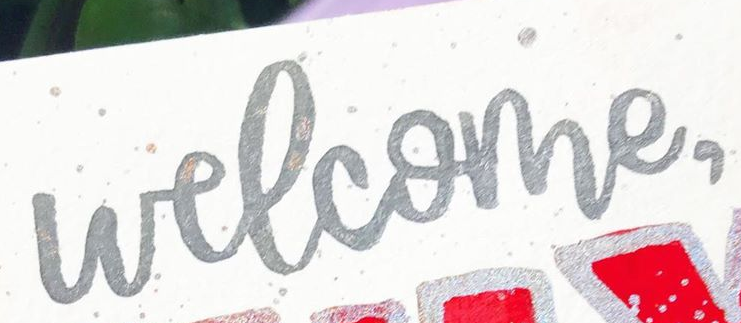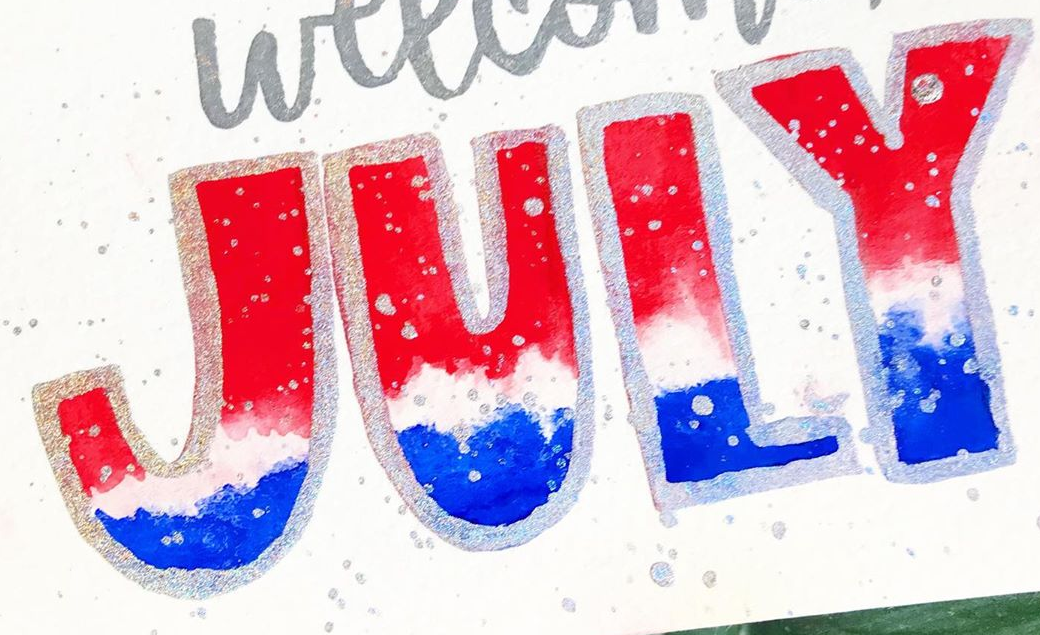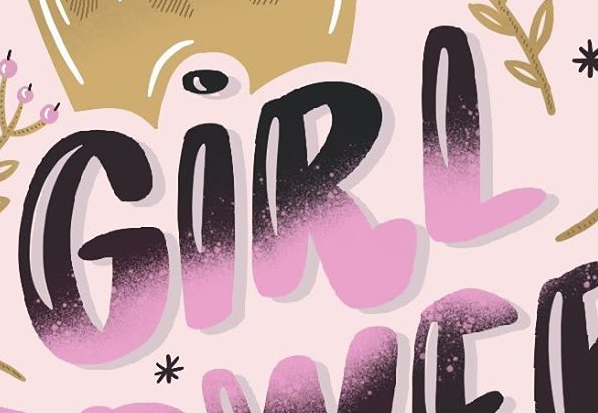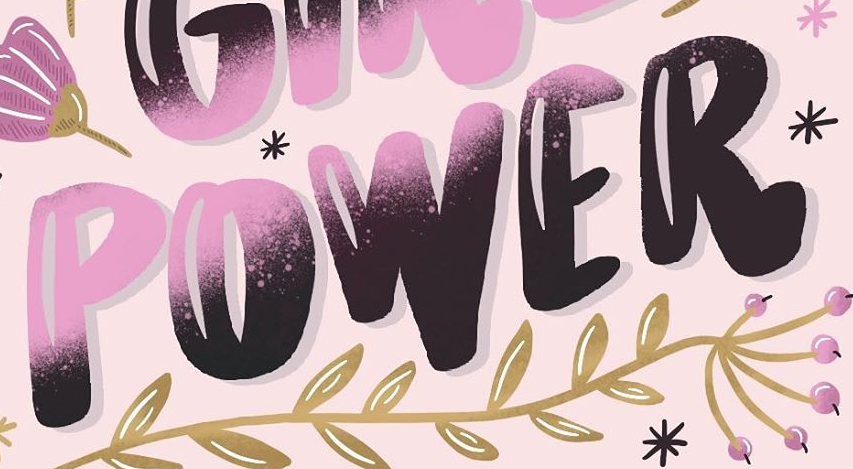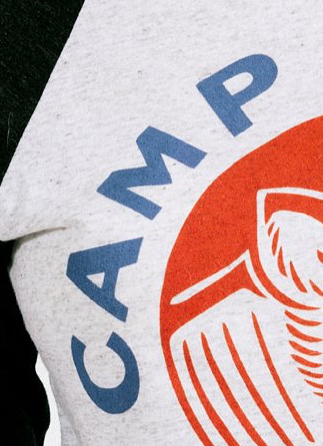What text appears in these images from left to right, separated by a semicolon? welcome,; JULY; GIRL; POWER; CAMP 